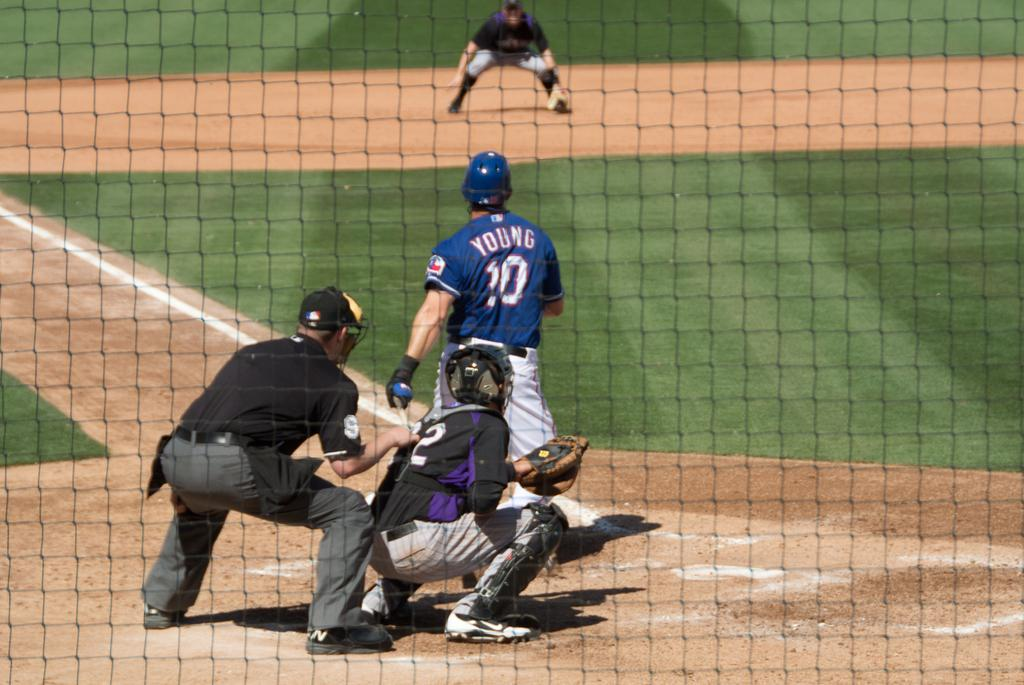What are the people in the image doing? The people in the image are playing a game. Can you describe the mesh in the foreground of the image? Yes, there is a mesh in the foreground of the image. Where is the machine located in the image? There is no machine present in the image. Is there a tent visible in the image? No, there is no tent present in the image. 